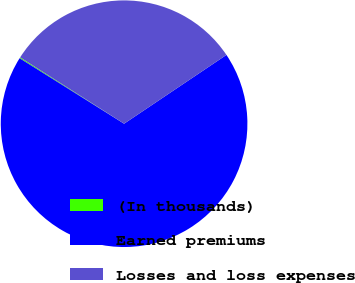Convert chart. <chart><loc_0><loc_0><loc_500><loc_500><pie_chart><fcel>(In thousands)<fcel>Earned premiums<fcel>Losses and loss expenses<nl><fcel>0.13%<fcel>68.32%<fcel>31.54%<nl></chart> 